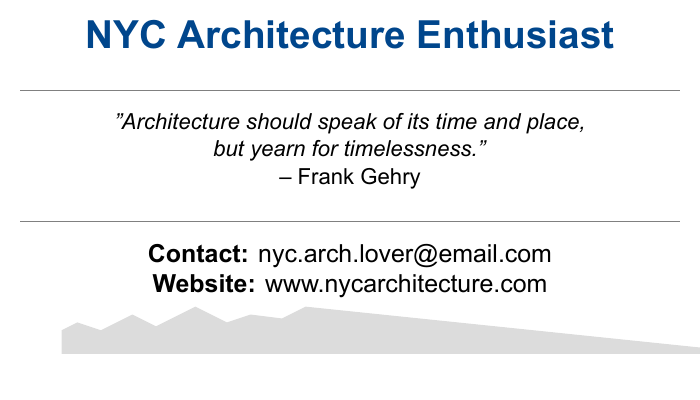What is the name of the quote's author? The quote on the business card is attributed to Frank Gehry.
Answer: Frank Gehry What is the email address listed? The document provides a specific email address for contact purposes.
Answer: nyc.arch.lover@email.com What is the main color used for the text? The document primarily uses a color defined as NYC blue for the text.
Answer: NYC blue What is the website mentioned? The document lists a specific website related to NYC architecture.
Answer: www.nycarchitecture.com How many lines are in the quote? The quote provided in the document contains two lines.
Answer: Two lines What type of document is this? This document is formatted to serve as a business card, specifically for an architecture enthusiast.
Answer: Business card What does the quote emphasize about architecture? The quote reflects on how architecture is related to its context and also aims for timelessness.
Answer: Timelessness What background color is used for the skyline design? The document has a defined skyline color used for design elements at the bottom of the card.
Answer: Skyline color 